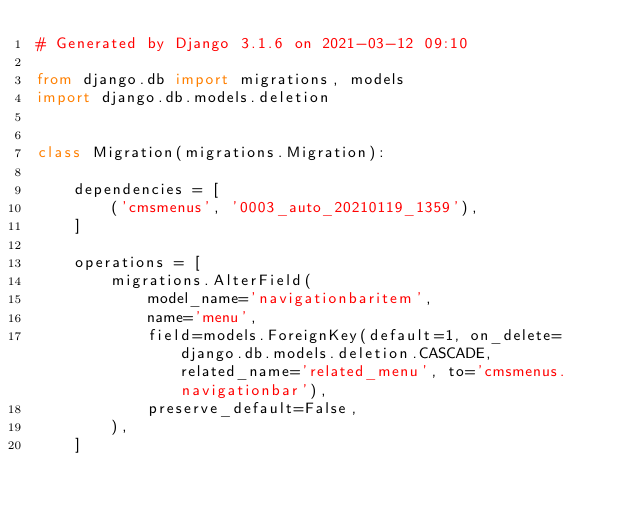<code> <loc_0><loc_0><loc_500><loc_500><_Python_># Generated by Django 3.1.6 on 2021-03-12 09:10

from django.db import migrations, models
import django.db.models.deletion


class Migration(migrations.Migration):

    dependencies = [
        ('cmsmenus', '0003_auto_20210119_1359'),
    ]

    operations = [
        migrations.AlterField(
            model_name='navigationbaritem',
            name='menu',
            field=models.ForeignKey(default=1, on_delete=django.db.models.deletion.CASCADE, related_name='related_menu', to='cmsmenus.navigationbar'),
            preserve_default=False,
        ),
    ]
</code> 